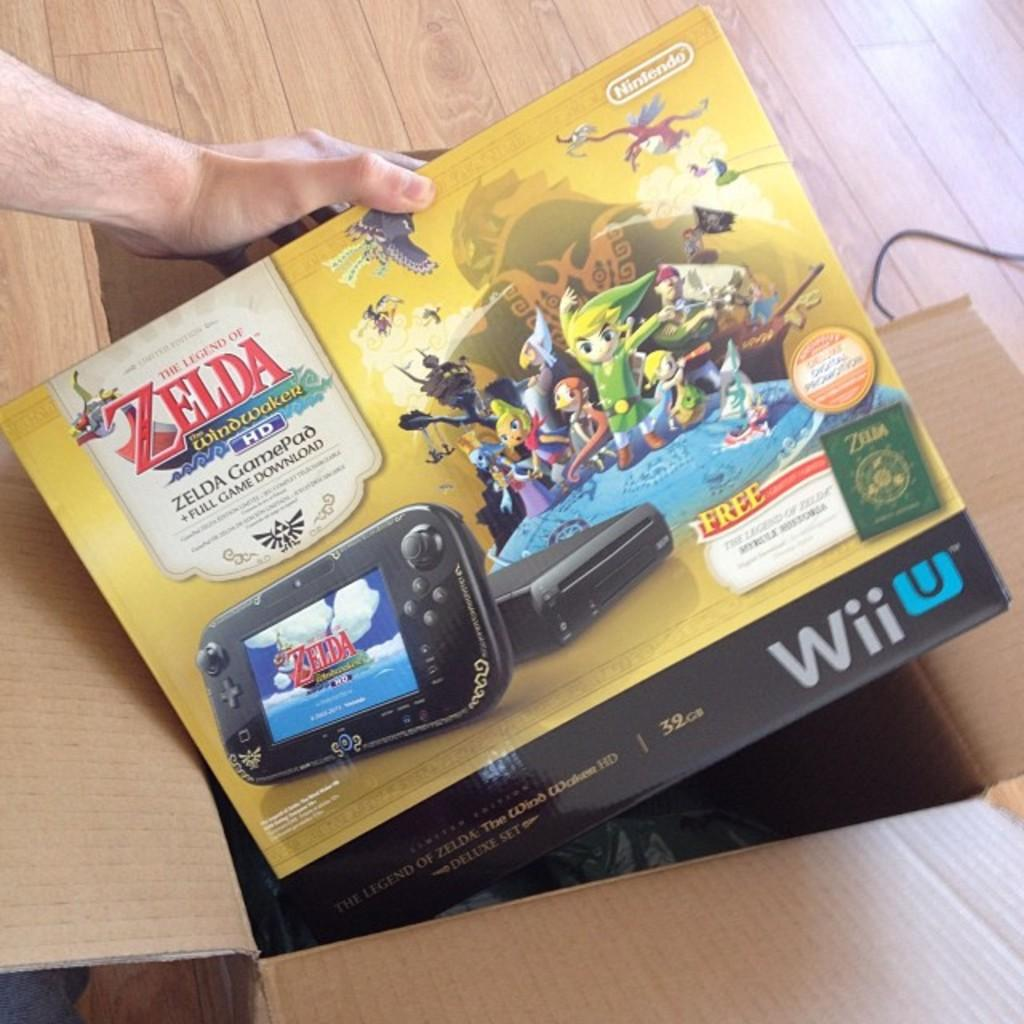<image>
Present a compact description of the photo's key features. A hand is holding a Wii U box that include the game The Legend of Zelda 